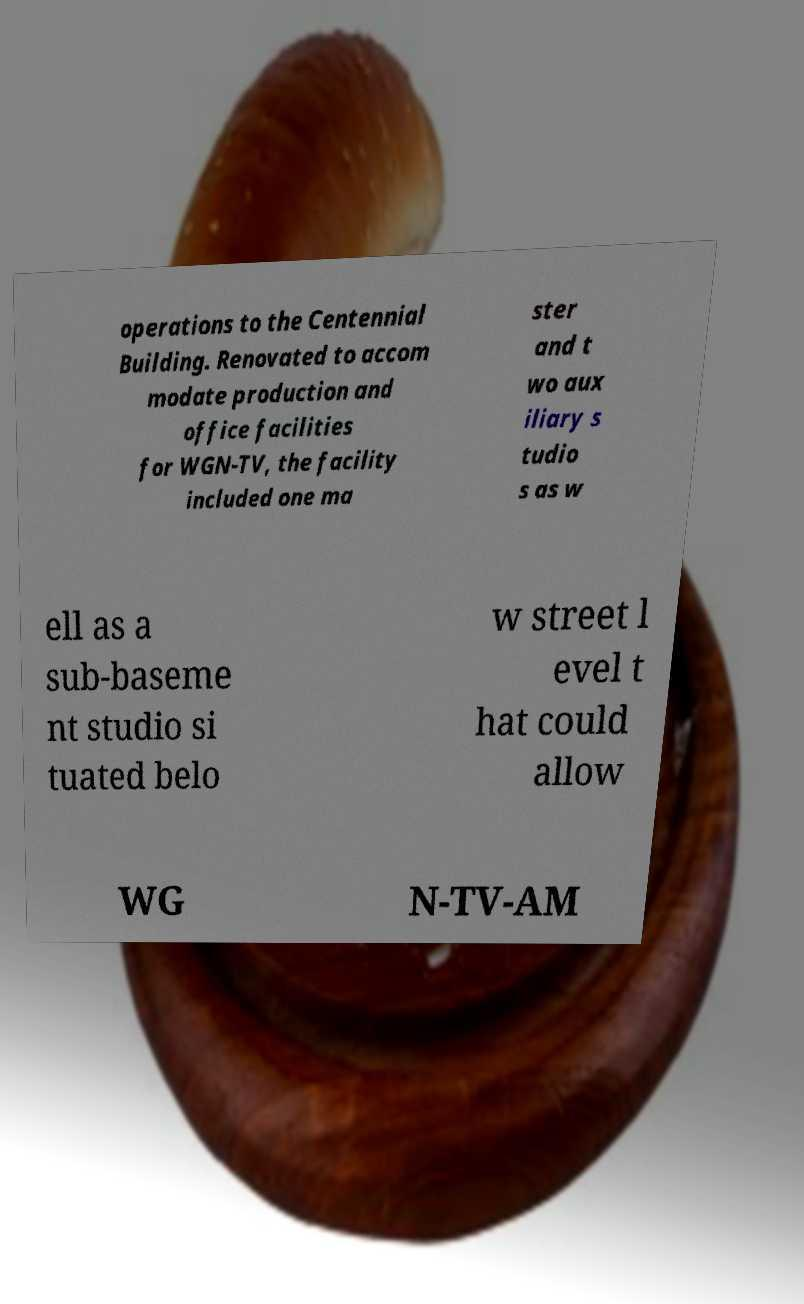I need the written content from this picture converted into text. Can you do that? operations to the Centennial Building. Renovated to accom modate production and office facilities for WGN-TV, the facility included one ma ster and t wo aux iliary s tudio s as w ell as a sub-baseme nt studio si tuated belo w street l evel t hat could allow WG N-TV-AM 